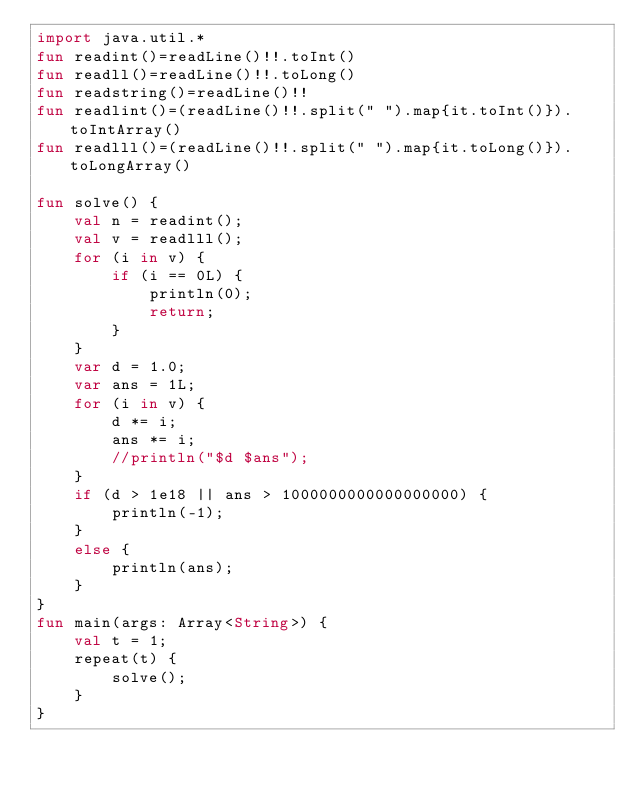Convert code to text. <code><loc_0><loc_0><loc_500><loc_500><_Kotlin_>import java.util.*
fun readint()=readLine()!!.toInt()
fun readll()=readLine()!!.toLong()
fun readstring()=readLine()!!
fun readlint()=(readLine()!!.split(" ").map{it.toInt()}).toIntArray()
fun readlll()=(readLine()!!.split(" ").map{it.toLong()}).toLongArray()

fun solve() {
    val n = readint();
    val v = readlll();
    for (i in v) {
        if (i == 0L) {
            println(0);
            return;
        }
    }
    var d = 1.0;
    var ans = 1L;
    for (i in v) {
        d *= i;
        ans *= i;
        //println("$d $ans");
    }
    if (d > 1e18 || ans > 1000000000000000000) {
        println(-1);
    }
    else {
        println(ans);
    }
}
fun main(args: Array<String>) {
    val t = 1;
    repeat(t) {
        solve();
    }
}</code> 